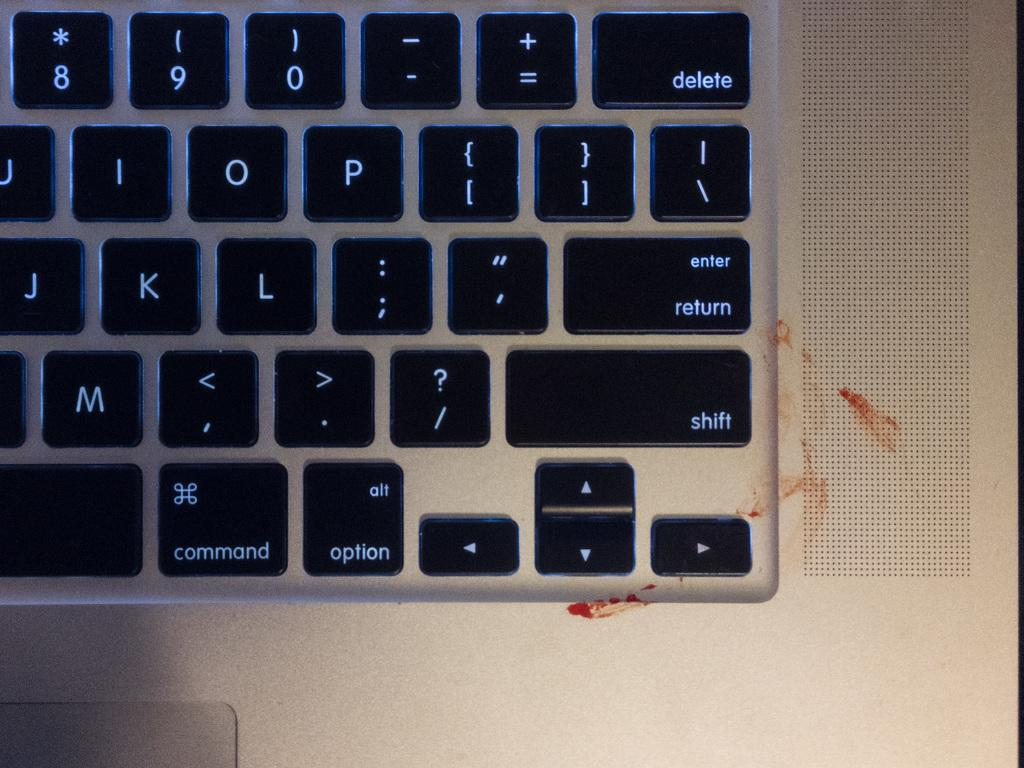<image>
Give a short and clear explanation of the subsequent image. Keyboard with the SHIFT key next to some blood. 